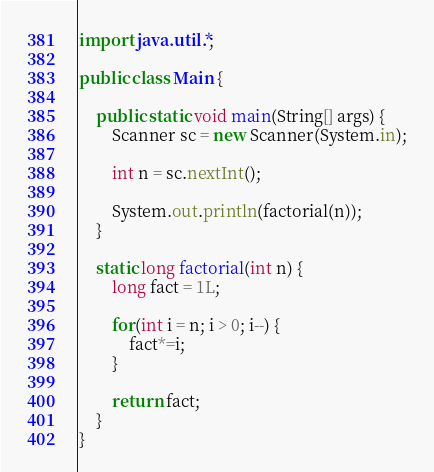<code> <loc_0><loc_0><loc_500><loc_500><_Java_>import java.util.*;

public class Main {
	
	public static void main(String[] args) {
		Scanner sc = new Scanner(System.in);
		
		int n = sc.nextInt();
		
		System.out.println(factorial(n));
	}
	
	static long factorial(int n) {
		long fact = 1L;
		
		for(int i = n; i > 0; i--) {
			fact*=i;
		}
		
		return fact;
	}
}</code> 